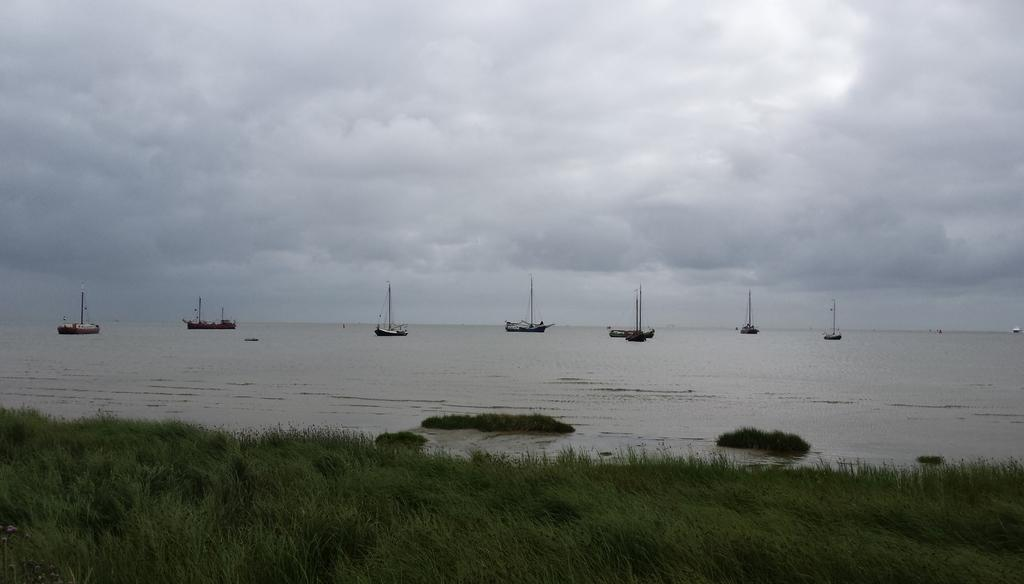What is in the water in the image? There are boats in the water in the image. What type of vegetation can be seen in the image? There is grass visible in the image. What is visible in the background of the image? The sky is visible in the background of the image. Where is the bag located in the image? There is no bag present in the image. What form does the hose take in the image? There is no hose present in the image. 